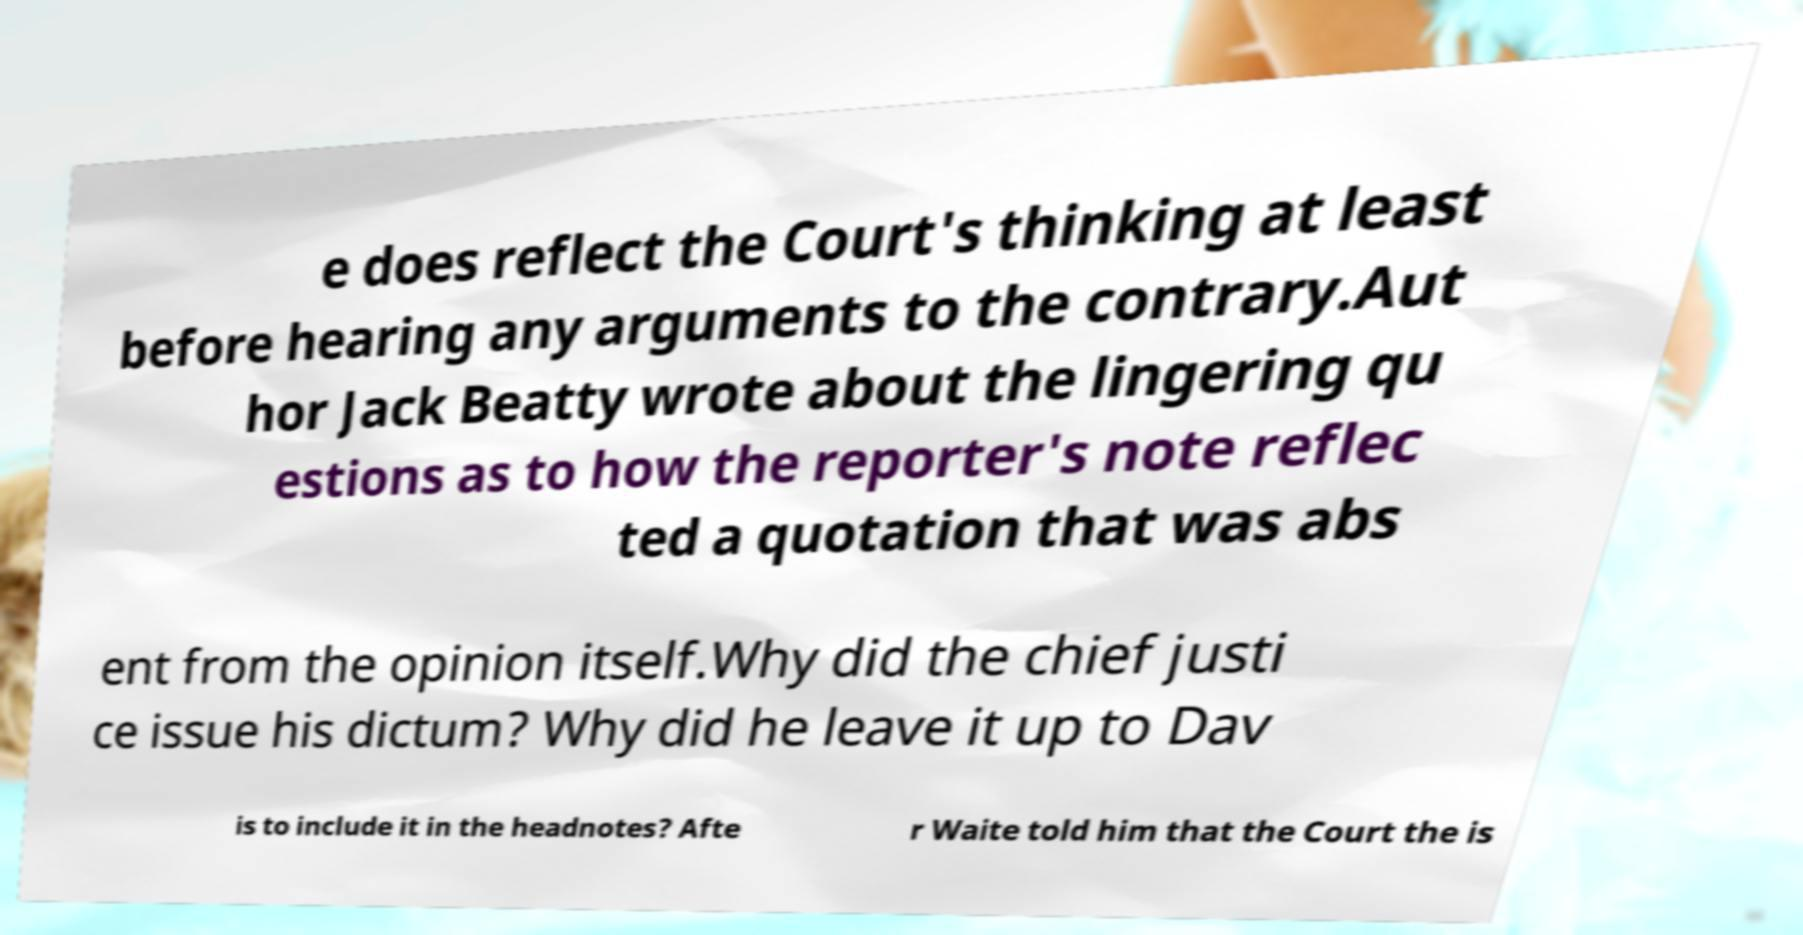Can you accurately transcribe the text from the provided image for me? e does reflect the Court's thinking at least before hearing any arguments to the contrary.Aut hor Jack Beatty wrote about the lingering qu estions as to how the reporter's note reflec ted a quotation that was abs ent from the opinion itself.Why did the chief justi ce issue his dictum? Why did he leave it up to Dav is to include it in the headnotes? Afte r Waite told him that the Court the is 